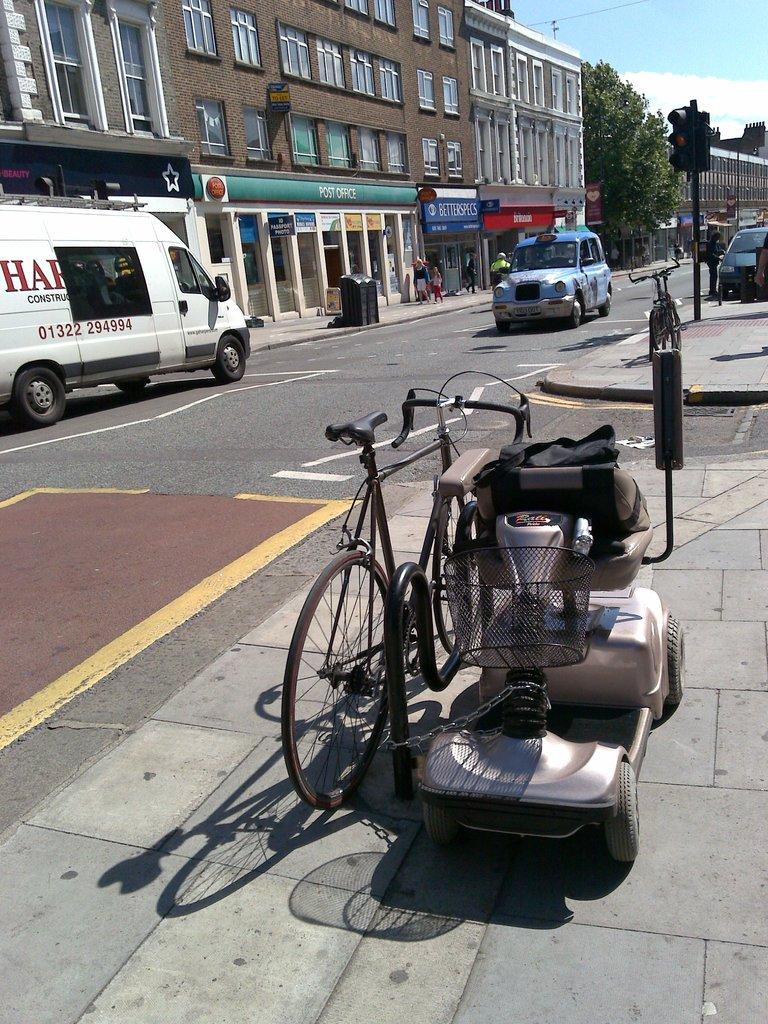Is the first number on the van to the left a zero?
Provide a short and direct response. Yes. 